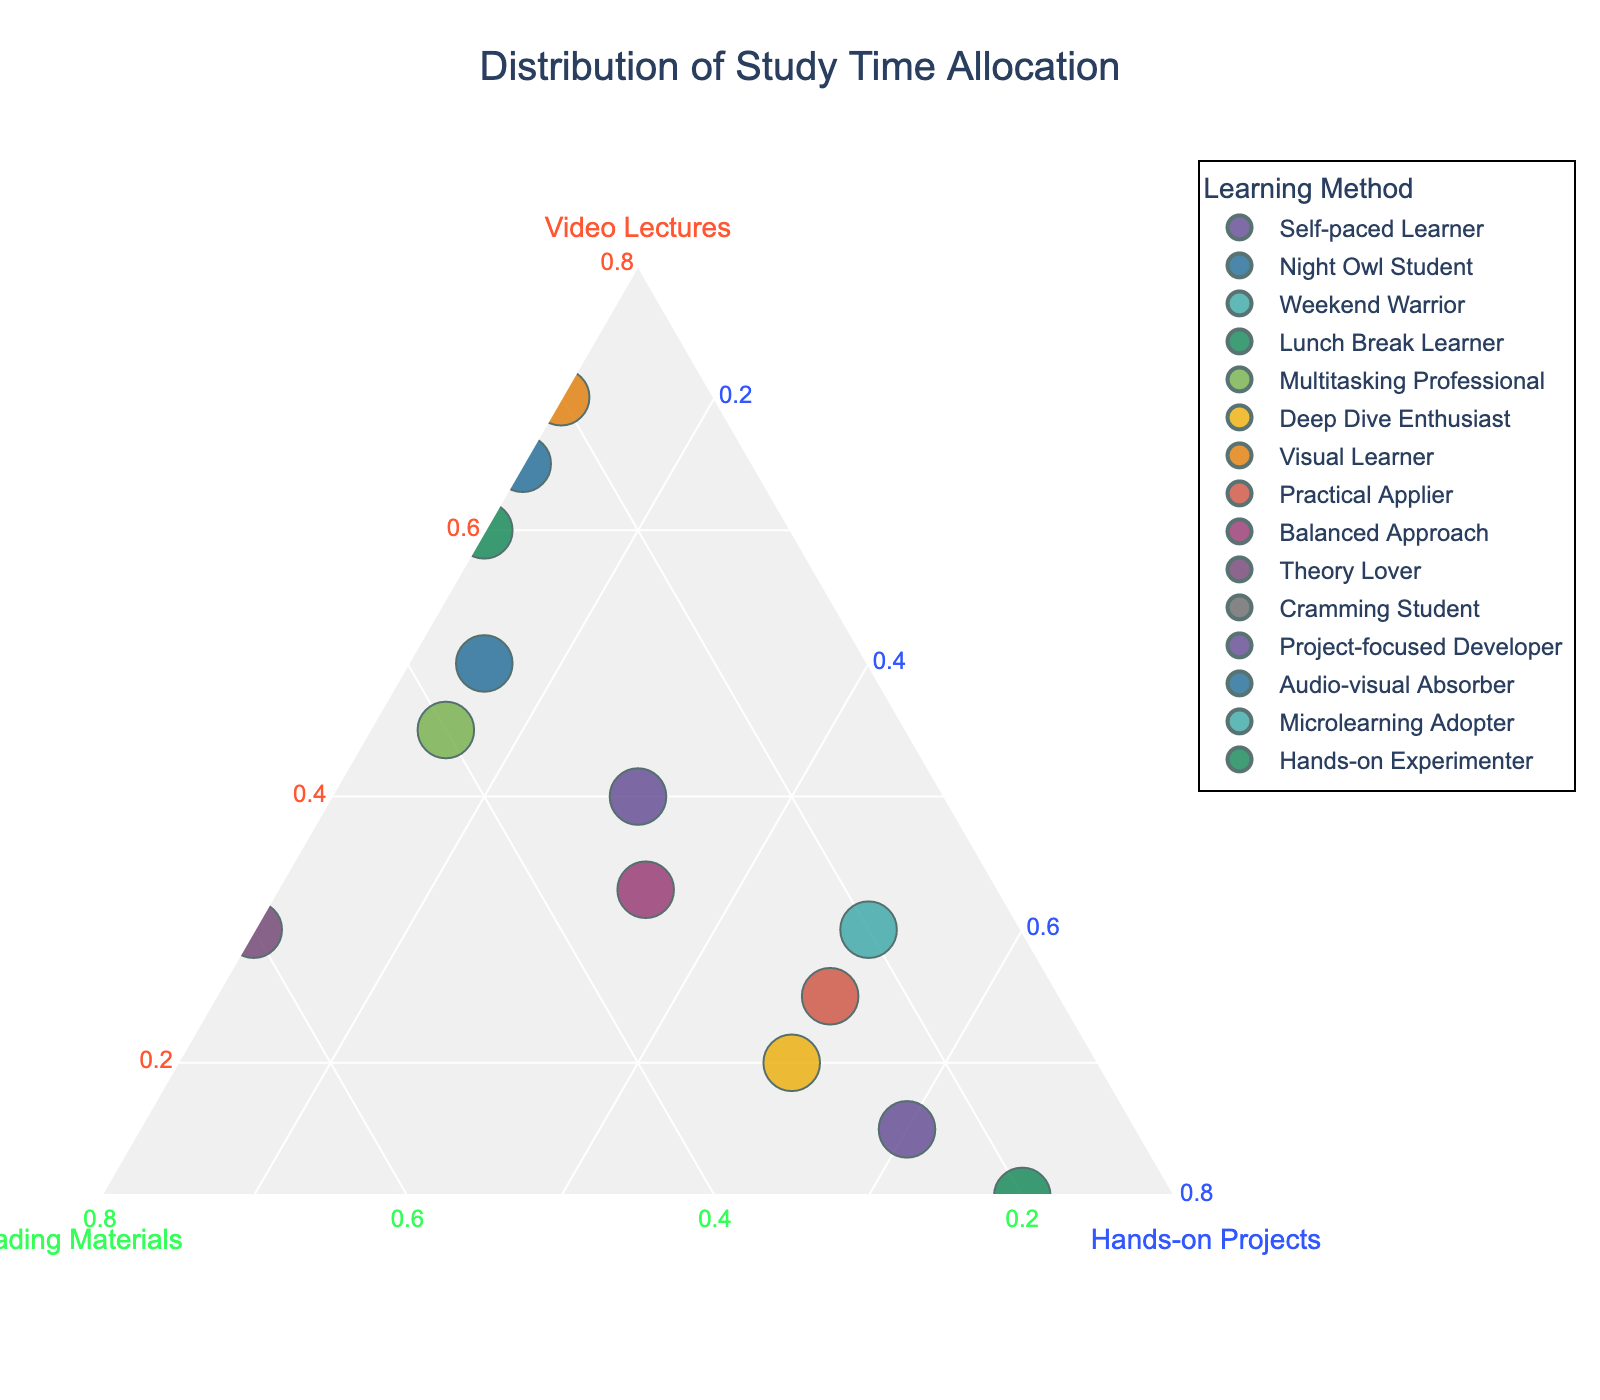What is the title of the plot? The title is found at the top of the plot. It provides a brief description of what the plot is about.
Answer: Distribution of Study Time Allocation How many data points are displayed in the plot? Count each unique Learning Method represented in the plot.
Answer: 15 Which learning method allocates the most time to "Hands-on Projects"? Look for the point that is closest to the corner representing Hands-on Projects (c-axis).
Answer: Hands-on Experimenter Which two learning methods allocate an equal amount of time to "Reading Materials"? Look for two points on the same line parallel to the line representing the proportion of Reading Materials (b-axis).
Answer: Self-paced Learner and Deep Dive Enthusiast What combination of learning methods allocates exactly 40% of their study time to "Video Lectures"? Check the points aligned with the 40% line on the Video Lectures axis (a-axis).
Answer: Self-paced Learner and Multitasking Professional Which learning method has the most balanced approach to all three learning methods? Identify the point closest to the center of the ternary plot, where all three ideals are equally represented.
Answer: Balanced Approach What is the difference in percentage allocation to "Video Lectures" between the "Visual Learner" and the "Night Owl Student"? Find the percentages allocated to "Video Lectures" by both learners and calculate the difference.
Answer: 20 (70 - 50) How does the "Theory Lover" allocate their study time among the three learning methods? Find the Theory Lover point and note down the respective percentages of each learning method.
Answer: Video Lectures: 30%, Reading Materials: 60%, Hands-on Projects: 10% Which learning method allocates relatively equal time to both "Video Lectures" and "Reading Materials"? Look for points that lie close to the line indicating equal portions of Video Lectures and Reading Materials.
Answer: Multitasking Professional 